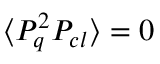Convert formula to latex. <formula><loc_0><loc_0><loc_500><loc_500>\langle P _ { q } ^ { 2 } P _ { c l } \rangle = 0</formula> 